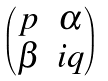<formula> <loc_0><loc_0><loc_500><loc_500>\begin{pmatrix} p & \alpha \\ \beta & i q \end{pmatrix}</formula> 